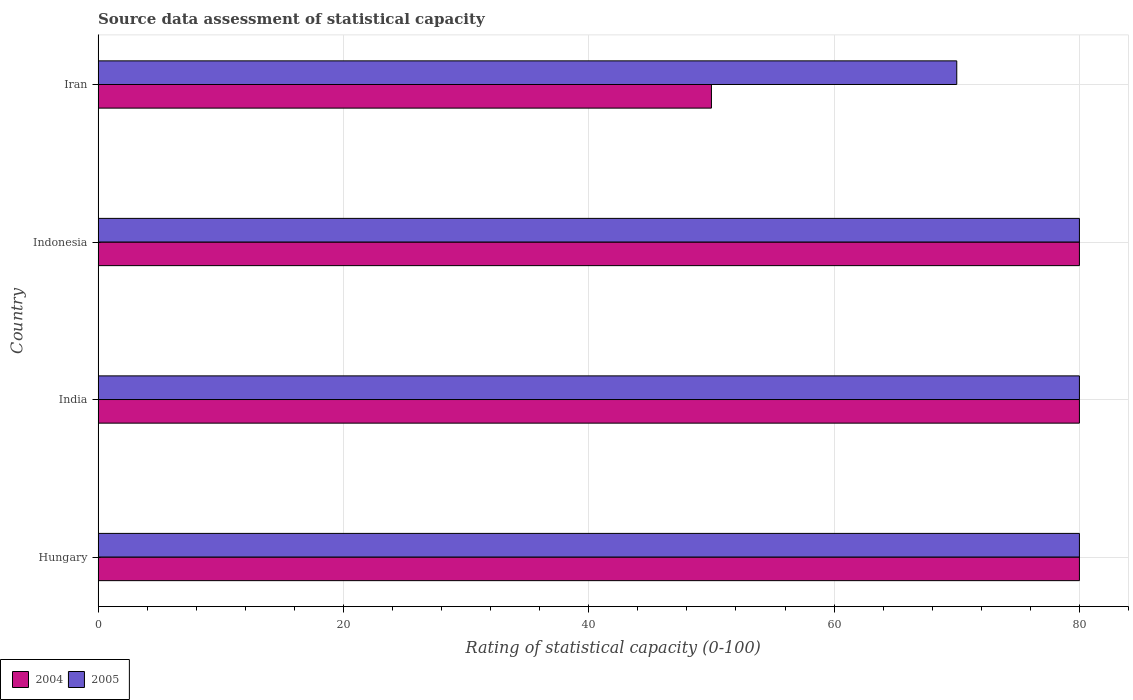Are the number of bars per tick equal to the number of legend labels?
Give a very brief answer. Yes. Are the number of bars on each tick of the Y-axis equal?
Make the answer very short. Yes. How many bars are there on the 1st tick from the bottom?
Give a very brief answer. 2. What is the label of the 4th group of bars from the top?
Give a very brief answer. Hungary. Across all countries, what is the minimum rating of statistical capacity in 2005?
Offer a very short reply. 70. In which country was the rating of statistical capacity in 2005 maximum?
Your answer should be very brief. Hungary. In which country was the rating of statistical capacity in 2004 minimum?
Offer a terse response. Iran. What is the total rating of statistical capacity in 2005 in the graph?
Your response must be concise. 310. What is the difference between the rating of statistical capacity in 2004 in India and that in Indonesia?
Provide a succinct answer. 0. What is the difference between the rating of statistical capacity in 2004 in India and the rating of statistical capacity in 2005 in Hungary?
Provide a succinct answer. 0. What is the average rating of statistical capacity in 2005 per country?
Provide a short and direct response. 77.5. What is the ratio of the rating of statistical capacity in 2005 in Hungary to that in Indonesia?
Your response must be concise. 1. Is the sum of the rating of statistical capacity in 2004 in Hungary and Iran greater than the maximum rating of statistical capacity in 2005 across all countries?
Keep it short and to the point. Yes. Are all the bars in the graph horizontal?
Offer a very short reply. Yes. What is the difference between two consecutive major ticks on the X-axis?
Offer a terse response. 20. Does the graph contain any zero values?
Your answer should be very brief. No. Does the graph contain grids?
Make the answer very short. Yes. Where does the legend appear in the graph?
Your answer should be very brief. Bottom left. How many legend labels are there?
Your answer should be very brief. 2. What is the title of the graph?
Offer a very short reply. Source data assessment of statistical capacity. Does "2013" appear as one of the legend labels in the graph?
Provide a succinct answer. No. What is the label or title of the X-axis?
Your answer should be compact. Rating of statistical capacity (0-100). What is the label or title of the Y-axis?
Give a very brief answer. Country. What is the Rating of statistical capacity (0-100) in 2004 in Hungary?
Provide a short and direct response. 80. What is the Rating of statistical capacity (0-100) in 2005 in Iran?
Your answer should be compact. 70. Across all countries, what is the maximum Rating of statistical capacity (0-100) of 2005?
Provide a short and direct response. 80. Across all countries, what is the minimum Rating of statistical capacity (0-100) in 2004?
Provide a short and direct response. 50. What is the total Rating of statistical capacity (0-100) in 2004 in the graph?
Make the answer very short. 290. What is the total Rating of statistical capacity (0-100) of 2005 in the graph?
Make the answer very short. 310. What is the difference between the Rating of statistical capacity (0-100) in 2004 in India and that in Iran?
Your answer should be very brief. 30. What is the difference between the Rating of statistical capacity (0-100) of 2005 in India and that in Iran?
Offer a very short reply. 10. What is the difference between the Rating of statistical capacity (0-100) of 2004 in Hungary and the Rating of statistical capacity (0-100) of 2005 in Indonesia?
Offer a very short reply. 0. What is the difference between the Rating of statistical capacity (0-100) in 2004 in Hungary and the Rating of statistical capacity (0-100) in 2005 in Iran?
Your answer should be compact. 10. What is the difference between the Rating of statistical capacity (0-100) of 2004 in India and the Rating of statistical capacity (0-100) of 2005 in Indonesia?
Your answer should be compact. 0. What is the average Rating of statistical capacity (0-100) in 2004 per country?
Provide a succinct answer. 72.5. What is the average Rating of statistical capacity (0-100) in 2005 per country?
Your response must be concise. 77.5. What is the difference between the Rating of statistical capacity (0-100) of 2004 and Rating of statistical capacity (0-100) of 2005 in India?
Ensure brevity in your answer.  0. What is the difference between the Rating of statistical capacity (0-100) of 2004 and Rating of statistical capacity (0-100) of 2005 in Indonesia?
Keep it short and to the point. 0. What is the difference between the Rating of statistical capacity (0-100) of 2004 and Rating of statistical capacity (0-100) of 2005 in Iran?
Your response must be concise. -20. What is the ratio of the Rating of statistical capacity (0-100) of 2005 in Hungary to that in India?
Provide a succinct answer. 1. What is the ratio of the Rating of statistical capacity (0-100) of 2004 in Hungary to that in Indonesia?
Give a very brief answer. 1. What is the ratio of the Rating of statistical capacity (0-100) in 2004 in India to that in Indonesia?
Offer a terse response. 1. What is the ratio of the Rating of statistical capacity (0-100) in 2005 in India to that in Indonesia?
Provide a short and direct response. 1. What is the ratio of the Rating of statistical capacity (0-100) in 2004 in India to that in Iran?
Offer a very short reply. 1.6. What is the ratio of the Rating of statistical capacity (0-100) in 2005 in Indonesia to that in Iran?
Make the answer very short. 1.14. What is the difference between the highest and the second highest Rating of statistical capacity (0-100) in 2005?
Provide a short and direct response. 0. What is the difference between the highest and the lowest Rating of statistical capacity (0-100) of 2004?
Provide a short and direct response. 30. What is the difference between the highest and the lowest Rating of statistical capacity (0-100) of 2005?
Your response must be concise. 10. 